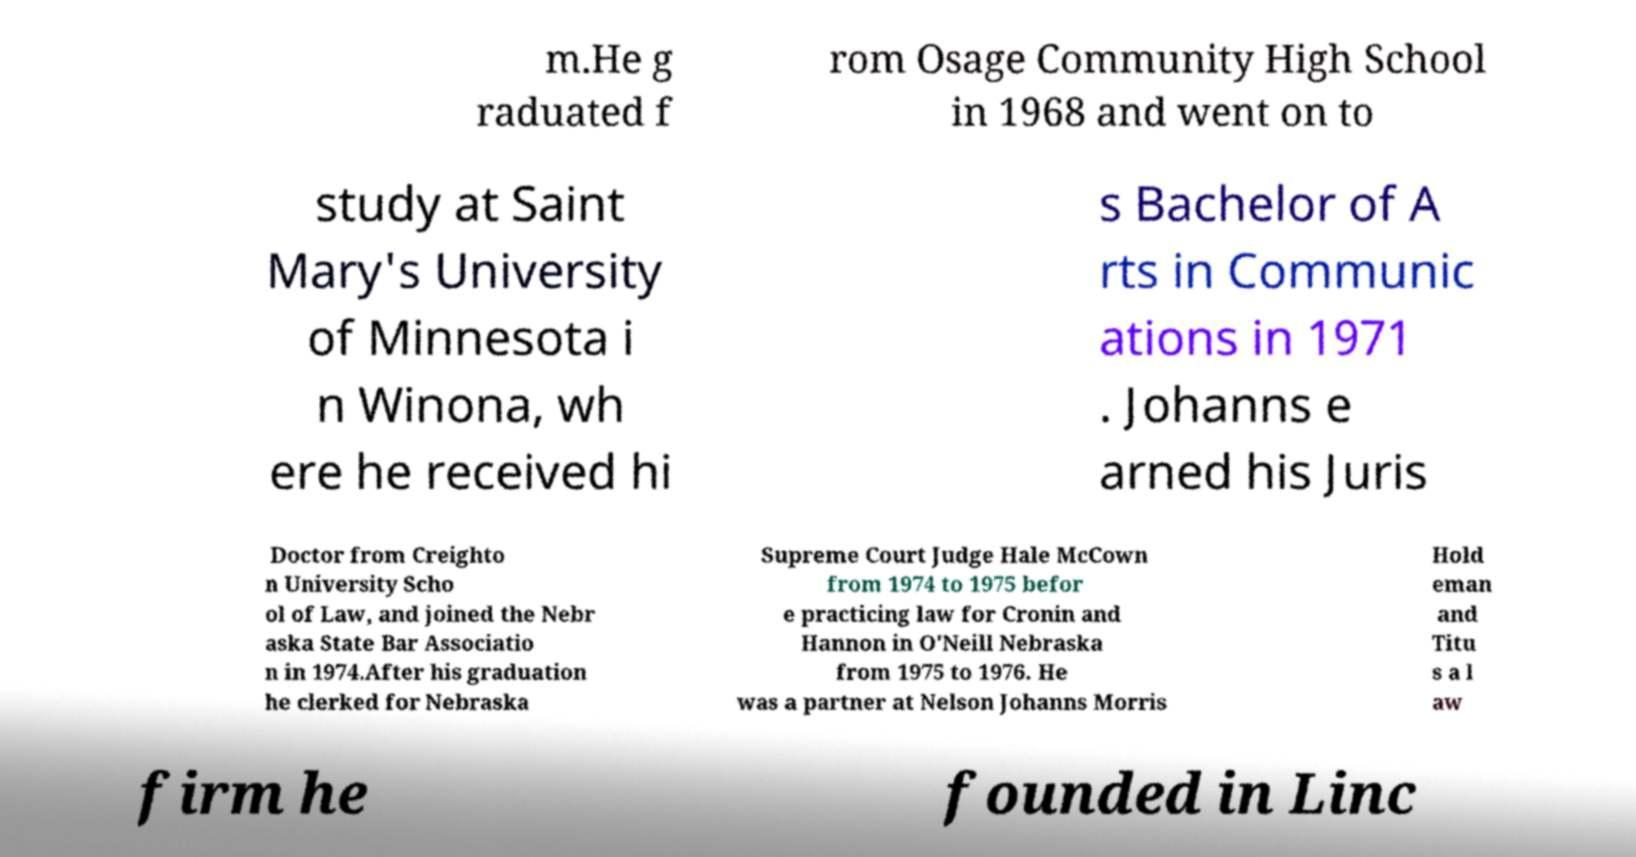I need the written content from this picture converted into text. Can you do that? m.He g raduated f rom Osage Community High School in 1968 and went on to study at Saint Mary's University of Minnesota i n Winona, wh ere he received hi s Bachelor of A rts in Communic ations in 1971 . Johanns e arned his Juris Doctor from Creighto n University Scho ol of Law, and joined the Nebr aska State Bar Associatio n in 1974.After his graduation he clerked for Nebraska Supreme Court Judge Hale McCown from 1974 to 1975 befor e practicing law for Cronin and Hannon in O'Neill Nebraska from 1975 to 1976. He was a partner at Nelson Johanns Morris Hold eman and Titu s a l aw firm he founded in Linc 